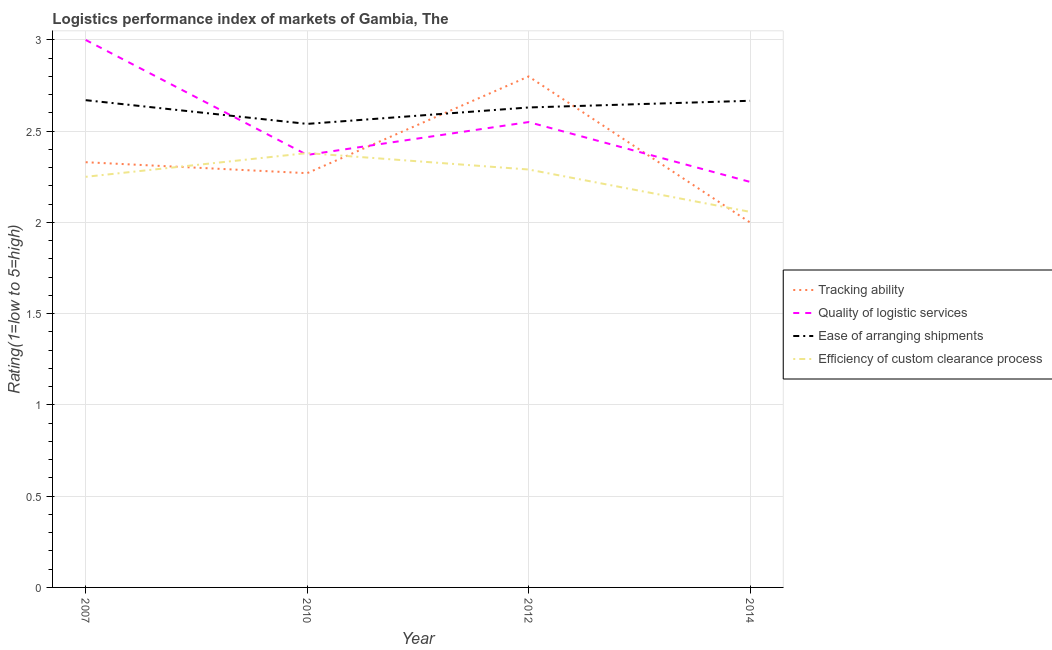How many different coloured lines are there?
Your answer should be very brief. 4. Does the line corresponding to lpi rating of quality of logistic services intersect with the line corresponding to lpi rating of efficiency of custom clearance process?
Give a very brief answer. Yes. Is the number of lines equal to the number of legend labels?
Offer a terse response. Yes. What is the lpi rating of efficiency of custom clearance process in 2010?
Your response must be concise. 2.38. Across all years, what is the minimum lpi rating of ease of arranging shipments?
Keep it short and to the point. 2.54. In which year was the lpi rating of ease of arranging shipments maximum?
Make the answer very short. 2007. In which year was the lpi rating of efficiency of custom clearance process minimum?
Give a very brief answer. 2014. What is the total lpi rating of tracking ability in the graph?
Make the answer very short. 9.4. What is the difference between the lpi rating of efficiency of custom clearance process in 2007 and that in 2014?
Provide a succinct answer. 0.19. What is the difference between the lpi rating of quality of logistic services in 2014 and the lpi rating of tracking ability in 2007?
Provide a short and direct response. -0.11. What is the average lpi rating of tracking ability per year?
Ensure brevity in your answer.  2.35. In the year 2007, what is the difference between the lpi rating of tracking ability and lpi rating of efficiency of custom clearance process?
Give a very brief answer. 0.08. In how many years, is the lpi rating of quality of logistic services greater than 1.2?
Your answer should be very brief. 4. What is the ratio of the lpi rating of efficiency of custom clearance process in 2007 to that in 2012?
Provide a succinct answer. 0.98. Is the lpi rating of tracking ability in 2007 less than that in 2012?
Your answer should be very brief. Yes. Is the difference between the lpi rating of quality of logistic services in 2010 and 2012 greater than the difference between the lpi rating of ease of arranging shipments in 2010 and 2012?
Your answer should be very brief. No. What is the difference between the highest and the second highest lpi rating of efficiency of custom clearance process?
Your response must be concise. 0.09. What is the difference between the highest and the lowest lpi rating of ease of arranging shipments?
Ensure brevity in your answer.  0.13. In how many years, is the lpi rating of quality of logistic services greater than the average lpi rating of quality of logistic services taken over all years?
Ensure brevity in your answer.  2. Does the lpi rating of tracking ability monotonically increase over the years?
Give a very brief answer. No. Are the values on the major ticks of Y-axis written in scientific E-notation?
Provide a short and direct response. No. Does the graph contain any zero values?
Make the answer very short. No. Does the graph contain grids?
Your answer should be very brief. Yes. Where does the legend appear in the graph?
Your answer should be compact. Center right. How are the legend labels stacked?
Keep it short and to the point. Vertical. What is the title of the graph?
Your answer should be compact. Logistics performance index of markets of Gambia, The. Does "Manufacturing" appear as one of the legend labels in the graph?
Keep it short and to the point. No. What is the label or title of the Y-axis?
Ensure brevity in your answer.  Rating(1=low to 5=high). What is the Rating(1=low to 5=high) in Tracking ability in 2007?
Provide a short and direct response. 2.33. What is the Rating(1=low to 5=high) in Ease of arranging shipments in 2007?
Provide a succinct answer. 2.67. What is the Rating(1=low to 5=high) in Efficiency of custom clearance process in 2007?
Provide a succinct answer. 2.25. What is the Rating(1=low to 5=high) in Tracking ability in 2010?
Offer a terse response. 2.27. What is the Rating(1=low to 5=high) in Quality of logistic services in 2010?
Your answer should be very brief. 2.37. What is the Rating(1=low to 5=high) of Ease of arranging shipments in 2010?
Your response must be concise. 2.54. What is the Rating(1=low to 5=high) of Efficiency of custom clearance process in 2010?
Keep it short and to the point. 2.38. What is the Rating(1=low to 5=high) of Quality of logistic services in 2012?
Provide a succinct answer. 2.55. What is the Rating(1=low to 5=high) of Ease of arranging shipments in 2012?
Give a very brief answer. 2.63. What is the Rating(1=low to 5=high) in Efficiency of custom clearance process in 2012?
Your answer should be very brief. 2.29. What is the Rating(1=low to 5=high) of Quality of logistic services in 2014?
Offer a very short reply. 2.22. What is the Rating(1=low to 5=high) in Ease of arranging shipments in 2014?
Provide a succinct answer. 2.67. What is the Rating(1=low to 5=high) of Efficiency of custom clearance process in 2014?
Your answer should be very brief. 2.06. Across all years, what is the maximum Rating(1=low to 5=high) in Quality of logistic services?
Provide a succinct answer. 3. Across all years, what is the maximum Rating(1=low to 5=high) in Ease of arranging shipments?
Provide a succinct answer. 2.67. Across all years, what is the maximum Rating(1=low to 5=high) of Efficiency of custom clearance process?
Provide a succinct answer. 2.38. Across all years, what is the minimum Rating(1=low to 5=high) in Quality of logistic services?
Keep it short and to the point. 2.22. Across all years, what is the minimum Rating(1=low to 5=high) of Ease of arranging shipments?
Give a very brief answer. 2.54. Across all years, what is the minimum Rating(1=low to 5=high) in Efficiency of custom clearance process?
Make the answer very short. 2.06. What is the total Rating(1=low to 5=high) of Tracking ability in the graph?
Provide a short and direct response. 9.4. What is the total Rating(1=low to 5=high) of Quality of logistic services in the graph?
Your answer should be compact. 10.14. What is the total Rating(1=low to 5=high) in Ease of arranging shipments in the graph?
Give a very brief answer. 10.51. What is the total Rating(1=low to 5=high) of Efficiency of custom clearance process in the graph?
Your answer should be very brief. 8.98. What is the difference between the Rating(1=low to 5=high) of Tracking ability in 2007 and that in 2010?
Keep it short and to the point. 0.06. What is the difference between the Rating(1=low to 5=high) of Quality of logistic services in 2007 and that in 2010?
Keep it short and to the point. 0.63. What is the difference between the Rating(1=low to 5=high) in Ease of arranging shipments in 2007 and that in 2010?
Your response must be concise. 0.13. What is the difference between the Rating(1=low to 5=high) of Efficiency of custom clearance process in 2007 and that in 2010?
Give a very brief answer. -0.13. What is the difference between the Rating(1=low to 5=high) in Tracking ability in 2007 and that in 2012?
Offer a very short reply. -0.47. What is the difference between the Rating(1=low to 5=high) of Quality of logistic services in 2007 and that in 2012?
Make the answer very short. 0.45. What is the difference between the Rating(1=low to 5=high) in Ease of arranging shipments in 2007 and that in 2012?
Give a very brief answer. 0.04. What is the difference between the Rating(1=low to 5=high) in Efficiency of custom clearance process in 2007 and that in 2012?
Your response must be concise. -0.04. What is the difference between the Rating(1=low to 5=high) in Tracking ability in 2007 and that in 2014?
Offer a very short reply. 0.33. What is the difference between the Rating(1=low to 5=high) of Ease of arranging shipments in 2007 and that in 2014?
Your answer should be compact. 0. What is the difference between the Rating(1=low to 5=high) in Efficiency of custom clearance process in 2007 and that in 2014?
Ensure brevity in your answer.  0.19. What is the difference between the Rating(1=low to 5=high) of Tracking ability in 2010 and that in 2012?
Your answer should be very brief. -0.53. What is the difference between the Rating(1=low to 5=high) in Quality of logistic services in 2010 and that in 2012?
Provide a short and direct response. -0.18. What is the difference between the Rating(1=low to 5=high) of Ease of arranging shipments in 2010 and that in 2012?
Your response must be concise. -0.09. What is the difference between the Rating(1=low to 5=high) of Efficiency of custom clearance process in 2010 and that in 2012?
Ensure brevity in your answer.  0.09. What is the difference between the Rating(1=low to 5=high) of Tracking ability in 2010 and that in 2014?
Make the answer very short. 0.27. What is the difference between the Rating(1=low to 5=high) in Quality of logistic services in 2010 and that in 2014?
Ensure brevity in your answer.  0.15. What is the difference between the Rating(1=low to 5=high) of Ease of arranging shipments in 2010 and that in 2014?
Make the answer very short. -0.13. What is the difference between the Rating(1=low to 5=high) in Efficiency of custom clearance process in 2010 and that in 2014?
Provide a succinct answer. 0.32. What is the difference between the Rating(1=low to 5=high) of Tracking ability in 2012 and that in 2014?
Your response must be concise. 0.8. What is the difference between the Rating(1=low to 5=high) of Quality of logistic services in 2012 and that in 2014?
Give a very brief answer. 0.33. What is the difference between the Rating(1=low to 5=high) of Ease of arranging shipments in 2012 and that in 2014?
Give a very brief answer. -0.04. What is the difference between the Rating(1=low to 5=high) in Efficiency of custom clearance process in 2012 and that in 2014?
Offer a terse response. 0.23. What is the difference between the Rating(1=low to 5=high) of Tracking ability in 2007 and the Rating(1=low to 5=high) of Quality of logistic services in 2010?
Your answer should be very brief. -0.04. What is the difference between the Rating(1=low to 5=high) of Tracking ability in 2007 and the Rating(1=low to 5=high) of Ease of arranging shipments in 2010?
Ensure brevity in your answer.  -0.21. What is the difference between the Rating(1=low to 5=high) in Quality of logistic services in 2007 and the Rating(1=low to 5=high) in Ease of arranging shipments in 2010?
Your answer should be compact. 0.46. What is the difference between the Rating(1=low to 5=high) in Quality of logistic services in 2007 and the Rating(1=low to 5=high) in Efficiency of custom clearance process in 2010?
Your answer should be compact. 0.62. What is the difference between the Rating(1=low to 5=high) in Ease of arranging shipments in 2007 and the Rating(1=low to 5=high) in Efficiency of custom clearance process in 2010?
Provide a succinct answer. 0.29. What is the difference between the Rating(1=low to 5=high) of Tracking ability in 2007 and the Rating(1=low to 5=high) of Quality of logistic services in 2012?
Your answer should be compact. -0.22. What is the difference between the Rating(1=low to 5=high) of Tracking ability in 2007 and the Rating(1=low to 5=high) of Efficiency of custom clearance process in 2012?
Offer a very short reply. 0.04. What is the difference between the Rating(1=low to 5=high) of Quality of logistic services in 2007 and the Rating(1=low to 5=high) of Ease of arranging shipments in 2012?
Offer a terse response. 0.37. What is the difference between the Rating(1=low to 5=high) in Quality of logistic services in 2007 and the Rating(1=low to 5=high) in Efficiency of custom clearance process in 2012?
Offer a terse response. 0.71. What is the difference between the Rating(1=low to 5=high) of Ease of arranging shipments in 2007 and the Rating(1=low to 5=high) of Efficiency of custom clearance process in 2012?
Your answer should be very brief. 0.38. What is the difference between the Rating(1=low to 5=high) in Tracking ability in 2007 and the Rating(1=low to 5=high) in Quality of logistic services in 2014?
Keep it short and to the point. 0.11. What is the difference between the Rating(1=low to 5=high) of Tracking ability in 2007 and the Rating(1=low to 5=high) of Ease of arranging shipments in 2014?
Your answer should be compact. -0.34. What is the difference between the Rating(1=low to 5=high) of Tracking ability in 2007 and the Rating(1=low to 5=high) of Efficiency of custom clearance process in 2014?
Your answer should be very brief. 0.27. What is the difference between the Rating(1=low to 5=high) of Quality of logistic services in 2007 and the Rating(1=low to 5=high) of Efficiency of custom clearance process in 2014?
Offer a terse response. 0.94. What is the difference between the Rating(1=low to 5=high) of Ease of arranging shipments in 2007 and the Rating(1=low to 5=high) of Efficiency of custom clearance process in 2014?
Ensure brevity in your answer.  0.61. What is the difference between the Rating(1=low to 5=high) of Tracking ability in 2010 and the Rating(1=low to 5=high) of Quality of logistic services in 2012?
Give a very brief answer. -0.28. What is the difference between the Rating(1=low to 5=high) of Tracking ability in 2010 and the Rating(1=low to 5=high) of Ease of arranging shipments in 2012?
Ensure brevity in your answer.  -0.36. What is the difference between the Rating(1=low to 5=high) of Tracking ability in 2010 and the Rating(1=low to 5=high) of Efficiency of custom clearance process in 2012?
Your answer should be compact. -0.02. What is the difference between the Rating(1=low to 5=high) in Quality of logistic services in 2010 and the Rating(1=low to 5=high) in Ease of arranging shipments in 2012?
Ensure brevity in your answer.  -0.26. What is the difference between the Rating(1=low to 5=high) in Tracking ability in 2010 and the Rating(1=low to 5=high) in Quality of logistic services in 2014?
Your answer should be compact. 0.05. What is the difference between the Rating(1=low to 5=high) in Tracking ability in 2010 and the Rating(1=low to 5=high) in Ease of arranging shipments in 2014?
Your response must be concise. -0.4. What is the difference between the Rating(1=low to 5=high) of Tracking ability in 2010 and the Rating(1=low to 5=high) of Efficiency of custom clearance process in 2014?
Ensure brevity in your answer.  0.21. What is the difference between the Rating(1=low to 5=high) in Quality of logistic services in 2010 and the Rating(1=low to 5=high) in Ease of arranging shipments in 2014?
Ensure brevity in your answer.  -0.3. What is the difference between the Rating(1=low to 5=high) of Quality of logistic services in 2010 and the Rating(1=low to 5=high) of Efficiency of custom clearance process in 2014?
Make the answer very short. 0.31. What is the difference between the Rating(1=low to 5=high) in Ease of arranging shipments in 2010 and the Rating(1=low to 5=high) in Efficiency of custom clearance process in 2014?
Offer a very short reply. 0.48. What is the difference between the Rating(1=low to 5=high) of Tracking ability in 2012 and the Rating(1=low to 5=high) of Quality of logistic services in 2014?
Provide a succinct answer. 0.58. What is the difference between the Rating(1=low to 5=high) in Tracking ability in 2012 and the Rating(1=low to 5=high) in Ease of arranging shipments in 2014?
Keep it short and to the point. 0.13. What is the difference between the Rating(1=low to 5=high) of Tracking ability in 2012 and the Rating(1=low to 5=high) of Efficiency of custom clearance process in 2014?
Offer a terse response. 0.74. What is the difference between the Rating(1=low to 5=high) in Quality of logistic services in 2012 and the Rating(1=low to 5=high) in Ease of arranging shipments in 2014?
Make the answer very short. -0.12. What is the difference between the Rating(1=low to 5=high) of Quality of logistic services in 2012 and the Rating(1=low to 5=high) of Efficiency of custom clearance process in 2014?
Your response must be concise. 0.49. What is the difference between the Rating(1=low to 5=high) in Ease of arranging shipments in 2012 and the Rating(1=low to 5=high) in Efficiency of custom clearance process in 2014?
Ensure brevity in your answer.  0.57. What is the average Rating(1=low to 5=high) in Tracking ability per year?
Provide a short and direct response. 2.35. What is the average Rating(1=low to 5=high) of Quality of logistic services per year?
Ensure brevity in your answer.  2.54. What is the average Rating(1=low to 5=high) in Ease of arranging shipments per year?
Provide a short and direct response. 2.63. What is the average Rating(1=low to 5=high) in Efficiency of custom clearance process per year?
Ensure brevity in your answer.  2.24. In the year 2007, what is the difference between the Rating(1=low to 5=high) in Tracking ability and Rating(1=low to 5=high) in Quality of logistic services?
Provide a succinct answer. -0.67. In the year 2007, what is the difference between the Rating(1=low to 5=high) of Tracking ability and Rating(1=low to 5=high) of Ease of arranging shipments?
Provide a succinct answer. -0.34. In the year 2007, what is the difference between the Rating(1=low to 5=high) of Quality of logistic services and Rating(1=low to 5=high) of Ease of arranging shipments?
Ensure brevity in your answer.  0.33. In the year 2007, what is the difference between the Rating(1=low to 5=high) of Ease of arranging shipments and Rating(1=low to 5=high) of Efficiency of custom clearance process?
Offer a terse response. 0.42. In the year 2010, what is the difference between the Rating(1=low to 5=high) in Tracking ability and Rating(1=low to 5=high) in Ease of arranging shipments?
Offer a very short reply. -0.27. In the year 2010, what is the difference between the Rating(1=low to 5=high) of Tracking ability and Rating(1=low to 5=high) of Efficiency of custom clearance process?
Provide a succinct answer. -0.11. In the year 2010, what is the difference between the Rating(1=low to 5=high) in Quality of logistic services and Rating(1=low to 5=high) in Ease of arranging shipments?
Give a very brief answer. -0.17. In the year 2010, what is the difference between the Rating(1=low to 5=high) of Quality of logistic services and Rating(1=low to 5=high) of Efficiency of custom clearance process?
Provide a succinct answer. -0.01. In the year 2010, what is the difference between the Rating(1=low to 5=high) of Ease of arranging shipments and Rating(1=low to 5=high) of Efficiency of custom clearance process?
Your answer should be compact. 0.16. In the year 2012, what is the difference between the Rating(1=low to 5=high) in Tracking ability and Rating(1=low to 5=high) in Quality of logistic services?
Ensure brevity in your answer.  0.25. In the year 2012, what is the difference between the Rating(1=low to 5=high) in Tracking ability and Rating(1=low to 5=high) in Ease of arranging shipments?
Your answer should be very brief. 0.17. In the year 2012, what is the difference between the Rating(1=low to 5=high) in Tracking ability and Rating(1=low to 5=high) in Efficiency of custom clearance process?
Make the answer very short. 0.51. In the year 2012, what is the difference between the Rating(1=low to 5=high) in Quality of logistic services and Rating(1=low to 5=high) in Ease of arranging shipments?
Your response must be concise. -0.08. In the year 2012, what is the difference between the Rating(1=low to 5=high) in Quality of logistic services and Rating(1=low to 5=high) in Efficiency of custom clearance process?
Give a very brief answer. 0.26. In the year 2012, what is the difference between the Rating(1=low to 5=high) in Ease of arranging shipments and Rating(1=low to 5=high) in Efficiency of custom clearance process?
Keep it short and to the point. 0.34. In the year 2014, what is the difference between the Rating(1=low to 5=high) of Tracking ability and Rating(1=low to 5=high) of Quality of logistic services?
Your answer should be compact. -0.22. In the year 2014, what is the difference between the Rating(1=low to 5=high) of Tracking ability and Rating(1=low to 5=high) of Efficiency of custom clearance process?
Your answer should be very brief. -0.06. In the year 2014, what is the difference between the Rating(1=low to 5=high) of Quality of logistic services and Rating(1=low to 5=high) of Ease of arranging shipments?
Offer a terse response. -0.44. In the year 2014, what is the difference between the Rating(1=low to 5=high) in Quality of logistic services and Rating(1=low to 5=high) in Efficiency of custom clearance process?
Offer a terse response. 0.16. In the year 2014, what is the difference between the Rating(1=low to 5=high) in Ease of arranging shipments and Rating(1=low to 5=high) in Efficiency of custom clearance process?
Offer a terse response. 0.61. What is the ratio of the Rating(1=low to 5=high) in Tracking ability in 2007 to that in 2010?
Provide a succinct answer. 1.03. What is the ratio of the Rating(1=low to 5=high) of Quality of logistic services in 2007 to that in 2010?
Provide a short and direct response. 1.27. What is the ratio of the Rating(1=low to 5=high) of Ease of arranging shipments in 2007 to that in 2010?
Offer a terse response. 1.05. What is the ratio of the Rating(1=low to 5=high) of Efficiency of custom clearance process in 2007 to that in 2010?
Your response must be concise. 0.95. What is the ratio of the Rating(1=low to 5=high) in Tracking ability in 2007 to that in 2012?
Your response must be concise. 0.83. What is the ratio of the Rating(1=low to 5=high) in Quality of logistic services in 2007 to that in 2012?
Offer a very short reply. 1.18. What is the ratio of the Rating(1=low to 5=high) in Ease of arranging shipments in 2007 to that in 2012?
Offer a very short reply. 1.02. What is the ratio of the Rating(1=low to 5=high) in Efficiency of custom clearance process in 2007 to that in 2012?
Ensure brevity in your answer.  0.98. What is the ratio of the Rating(1=low to 5=high) of Tracking ability in 2007 to that in 2014?
Provide a succinct answer. 1.17. What is the ratio of the Rating(1=low to 5=high) in Quality of logistic services in 2007 to that in 2014?
Keep it short and to the point. 1.35. What is the ratio of the Rating(1=low to 5=high) in Efficiency of custom clearance process in 2007 to that in 2014?
Your response must be concise. 1.09. What is the ratio of the Rating(1=low to 5=high) in Tracking ability in 2010 to that in 2012?
Make the answer very short. 0.81. What is the ratio of the Rating(1=low to 5=high) in Quality of logistic services in 2010 to that in 2012?
Provide a succinct answer. 0.93. What is the ratio of the Rating(1=low to 5=high) of Ease of arranging shipments in 2010 to that in 2012?
Provide a succinct answer. 0.97. What is the ratio of the Rating(1=low to 5=high) of Efficiency of custom clearance process in 2010 to that in 2012?
Your answer should be very brief. 1.04. What is the ratio of the Rating(1=low to 5=high) of Tracking ability in 2010 to that in 2014?
Provide a short and direct response. 1.14. What is the ratio of the Rating(1=low to 5=high) in Quality of logistic services in 2010 to that in 2014?
Provide a succinct answer. 1.07. What is the ratio of the Rating(1=low to 5=high) in Ease of arranging shipments in 2010 to that in 2014?
Your answer should be very brief. 0.95. What is the ratio of the Rating(1=low to 5=high) in Efficiency of custom clearance process in 2010 to that in 2014?
Your answer should be compact. 1.16. What is the ratio of the Rating(1=low to 5=high) of Tracking ability in 2012 to that in 2014?
Provide a succinct answer. 1.4. What is the ratio of the Rating(1=low to 5=high) of Quality of logistic services in 2012 to that in 2014?
Provide a succinct answer. 1.15. What is the ratio of the Rating(1=low to 5=high) of Ease of arranging shipments in 2012 to that in 2014?
Your response must be concise. 0.99. What is the ratio of the Rating(1=low to 5=high) of Efficiency of custom clearance process in 2012 to that in 2014?
Offer a very short reply. 1.11. What is the difference between the highest and the second highest Rating(1=low to 5=high) in Tracking ability?
Your response must be concise. 0.47. What is the difference between the highest and the second highest Rating(1=low to 5=high) of Quality of logistic services?
Your answer should be very brief. 0.45. What is the difference between the highest and the second highest Rating(1=low to 5=high) of Ease of arranging shipments?
Ensure brevity in your answer.  0. What is the difference between the highest and the second highest Rating(1=low to 5=high) in Efficiency of custom clearance process?
Offer a very short reply. 0.09. What is the difference between the highest and the lowest Rating(1=low to 5=high) in Tracking ability?
Your answer should be very brief. 0.8. What is the difference between the highest and the lowest Rating(1=low to 5=high) of Quality of logistic services?
Your answer should be compact. 0.78. What is the difference between the highest and the lowest Rating(1=low to 5=high) of Ease of arranging shipments?
Ensure brevity in your answer.  0.13. What is the difference between the highest and the lowest Rating(1=low to 5=high) of Efficiency of custom clearance process?
Ensure brevity in your answer.  0.32. 